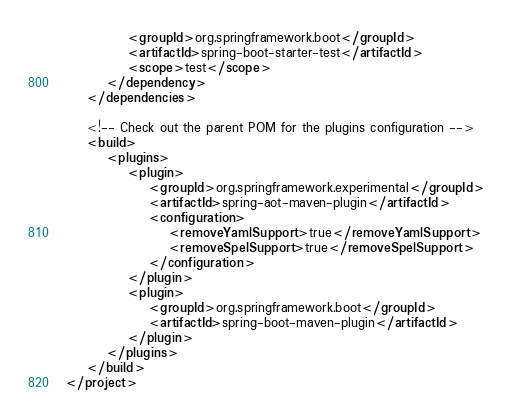<code> <loc_0><loc_0><loc_500><loc_500><_XML_>			<groupId>org.springframework.boot</groupId>
			<artifactId>spring-boot-starter-test</artifactId>
			<scope>test</scope>
		</dependency>
	</dependencies>

	<!-- Check out the parent POM for the plugins configuration -->
	<build>
		<plugins>
			<plugin>
				<groupId>org.springframework.experimental</groupId>
				<artifactId>spring-aot-maven-plugin</artifactId>
				<configuration>
					<removeYamlSupport>true</removeYamlSupport>
					<removeSpelSupport>true</removeSpelSupport>
				</configuration>
			</plugin>
			<plugin>
				<groupId>org.springframework.boot</groupId>
				<artifactId>spring-boot-maven-plugin</artifactId>
			</plugin>
		</plugins>
	</build>
</project>
</code> 